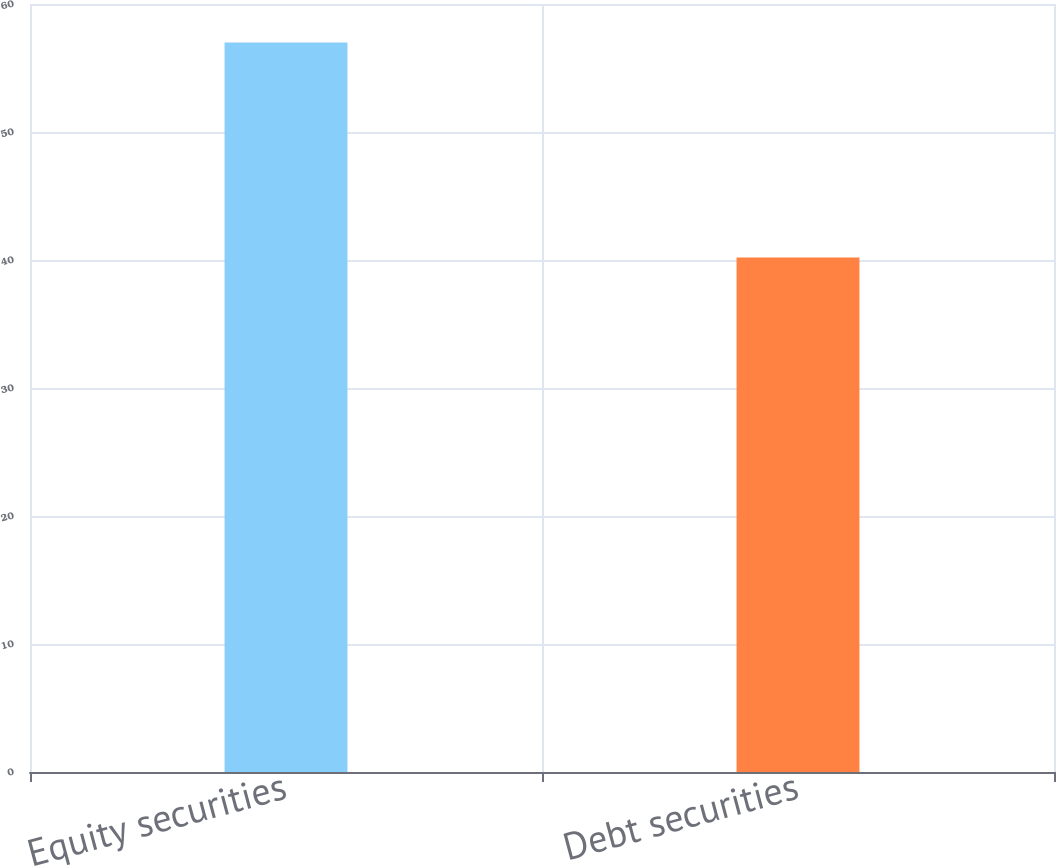Convert chart. <chart><loc_0><loc_0><loc_500><loc_500><bar_chart><fcel>Equity securities<fcel>Debt securities<nl><fcel>57<fcel>40.2<nl></chart> 